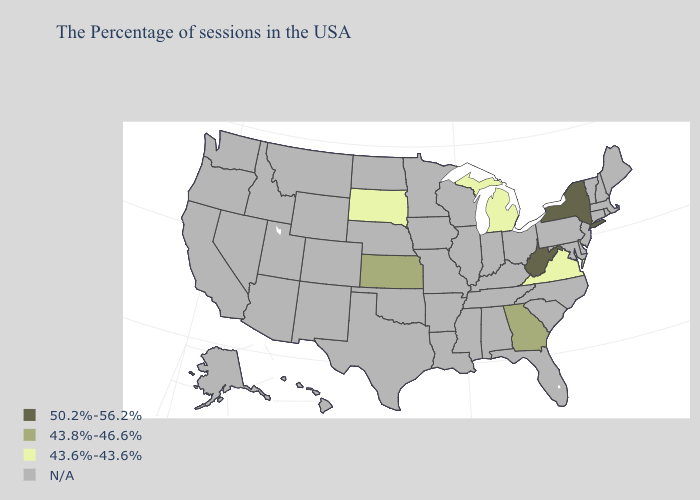Name the states that have a value in the range 50.2%-56.2%?
Be succinct. New York, West Virginia. Name the states that have a value in the range 50.2%-56.2%?
Write a very short answer. New York, West Virginia. Does Kansas have the highest value in the USA?
Write a very short answer. No. Among the states that border Alabama , which have the highest value?
Give a very brief answer. Georgia. What is the highest value in the USA?
Give a very brief answer. 50.2%-56.2%. Which states hav the highest value in the South?
Give a very brief answer. West Virginia. Is the legend a continuous bar?
Be succinct. No. What is the value of Texas?
Short answer required. N/A. What is the value of New Hampshire?
Short answer required. N/A. Does Virginia have the lowest value in the USA?
Answer briefly. Yes. What is the lowest value in the MidWest?
Write a very short answer. 43.6%-43.6%. Which states have the highest value in the USA?
Give a very brief answer. New York, West Virginia. How many symbols are there in the legend?
Keep it brief. 4. 